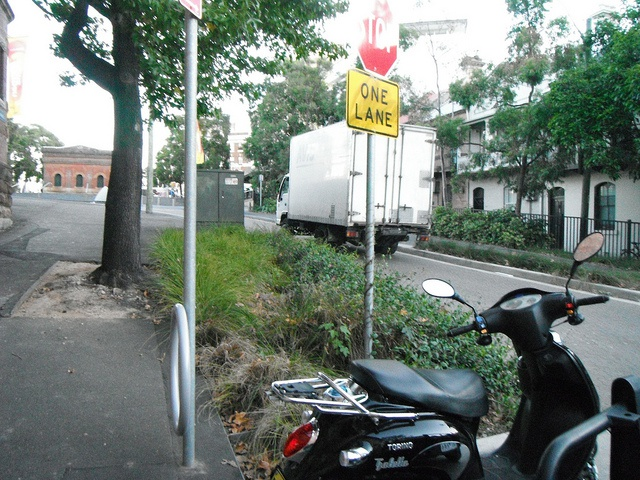Describe the objects in this image and their specific colors. I can see motorcycle in gray, black, and darkgray tones, truck in gray, white, black, and darkgray tones, truck in gray, white, darkgray, and black tones, and stop sign in gray, white, lightpink, and salmon tones in this image. 